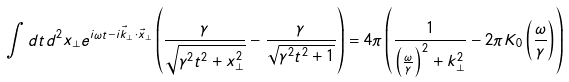<formula> <loc_0><loc_0><loc_500><loc_500>\int d t d ^ { 2 } x _ { \perp } e ^ { i \omega t - i \vec { k } _ { \perp } \cdot \vec { x } _ { \perp } } \left ( \frac { \gamma } { \sqrt { \gamma ^ { 2 } t ^ { 2 } + x _ { \perp } ^ { 2 } } } - \frac { \gamma } { \sqrt { \gamma ^ { 2 } t ^ { 2 } + 1 } } \right ) = 4 \pi \left ( \frac { 1 } { \left ( \frac { \omega } { \gamma } \right ) ^ { 2 } + k _ { \perp } ^ { 2 } } - 2 \pi K _ { 0 } \left ( \frac { \omega } { \gamma } \right ) \right )</formula> 